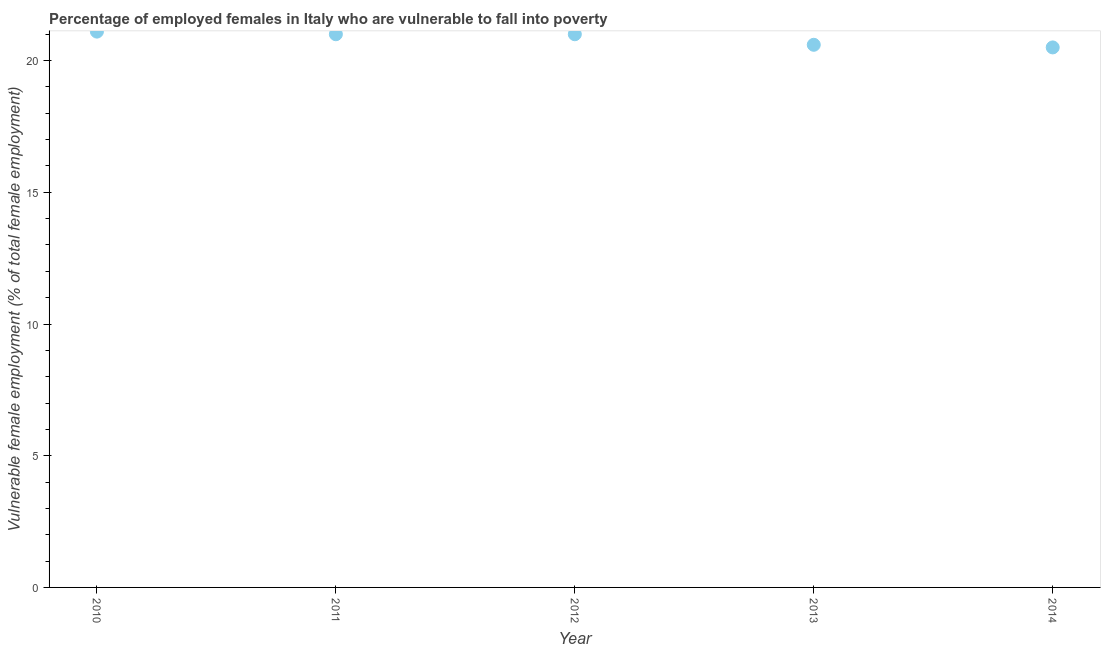Across all years, what is the maximum percentage of employed females who are vulnerable to fall into poverty?
Make the answer very short. 21.1. Across all years, what is the minimum percentage of employed females who are vulnerable to fall into poverty?
Your answer should be compact. 20.5. In which year was the percentage of employed females who are vulnerable to fall into poverty maximum?
Make the answer very short. 2010. What is the sum of the percentage of employed females who are vulnerable to fall into poverty?
Offer a very short reply. 104.2. What is the difference between the percentage of employed females who are vulnerable to fall into poverty in 2010 and 2011?
Offer a very short reply. 0.1. What is the average percentage of employed females who are vulnerable to fall into poverty per year?
Your answer should be compact. 20.84. In how many years, is the percentage of employed females who are vulnerable to fall into poverty greater than 10 %?
Your answer should be compact. 5. What is the ratio of the percentage of employed females who are vulnerable to fall into poverty in 2010 to that in 2013?
Offer a terse response. 1.02. Is the percentage of employed females who are vulnerable to fall into poverty in 2010 less than that in 2014?
Keep it short and to the point. No. Is the difference between the percentage of employed females who are vulnerable to fall into poverty in 2011 and 2012 greater than the difference between any two years?
Offer a very short reply. No. What is the difference between the highest and the second highest percentage of employed females who are vulnerable to fall into poverty?
Offer a terse response. 0.1. Is the sum of the percentage of employed females who are vulnerable to fall into poverty in 2010 and 2013 greater than the maximum percentage of employed females who are vulnerable to fall into poverty across all years?
Offer a very short reply. Yes. What is the difference between the highest and the lowest percentage of employed females who are vulnerable to fall into poverty?
Make the answer very short. 0.6. What is the title of the graph?
Offer a terse response. Percentage of employed females in Italy who are vulnerable to fall into poverty. What is the label or title of the X-axis?
Ensure brevity in your answer.  Year. What is the label or title of the Y-axis?
Ensure brevity in your answer.  Vulnerable female employment (% of total female employment). What is the Vulnerable female employment (% of total female employment) in 2010?
Your answer should be compact. 21.1. What is the Vulnerable female employment (% of total female employment) in 2012?
Your answer should be compact. 21. What is the Vulnerable female employment (% of total female employment) in 2013?
Provide a short and direct response. 20.6. What is the difference between the Vulnerable female employment (% of total female employment) in 2011 and 2012?
Give a very brief answer. 0. What is the difference between the Vulnerable female employment (% of total female employment) in 2011 and 2013?
Offer a very short reply. 0.4. What is the difference between the Vulnerable female employment (% of total female employment) in 2013 and 2014?
Provide a succinct answer. 0.1. What is the ratio of the Vulnerable female employment (% of total female employment) in 2010 to that in 2013?
Keep it short and to the point. 1.02. What is the ratio of the Vulnerable female employment (% of total female employment) in 2011 to that in 2012?
Provide a short and direct response. 1. What is the ratio of the Vulnerable female employment (% of total female employment) in 2012 to that in 2013?
Offer a terse response. 1.02. What is the ratio of the Vulnerable female employment (% of total female employment) in 2013 to that in 2014?
Offer a very short reply. 1. 